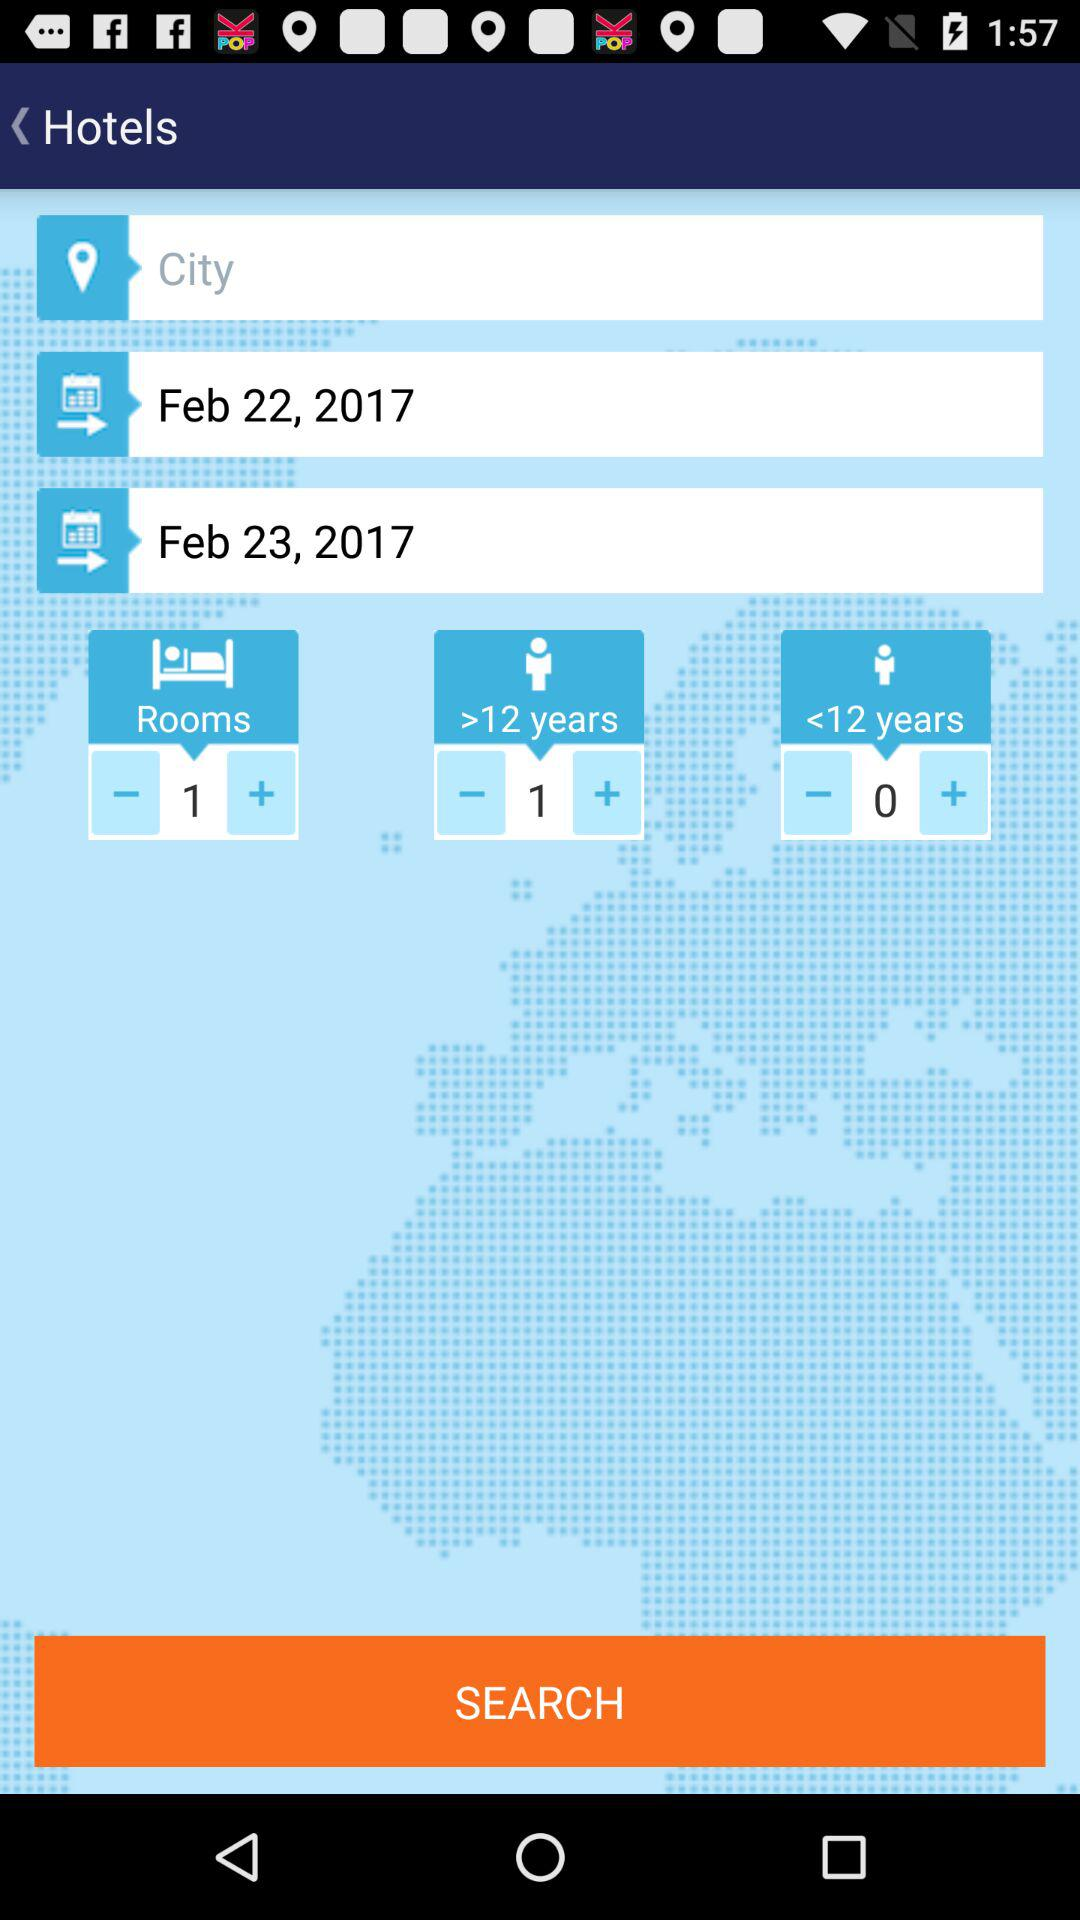How many children are there? There are 0 children. 